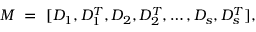Convert formula to latex. <formula><loc_0><loc_0><loc_500><loc_500>M \ = \ [ D _ { 1 } , D _ { 1 } ^ { T } , D _ { 2 } , D _ { 2 } ^ { T } , \dots , D _ { s } , D _ { s } ^ { T } ] ,</formula> 